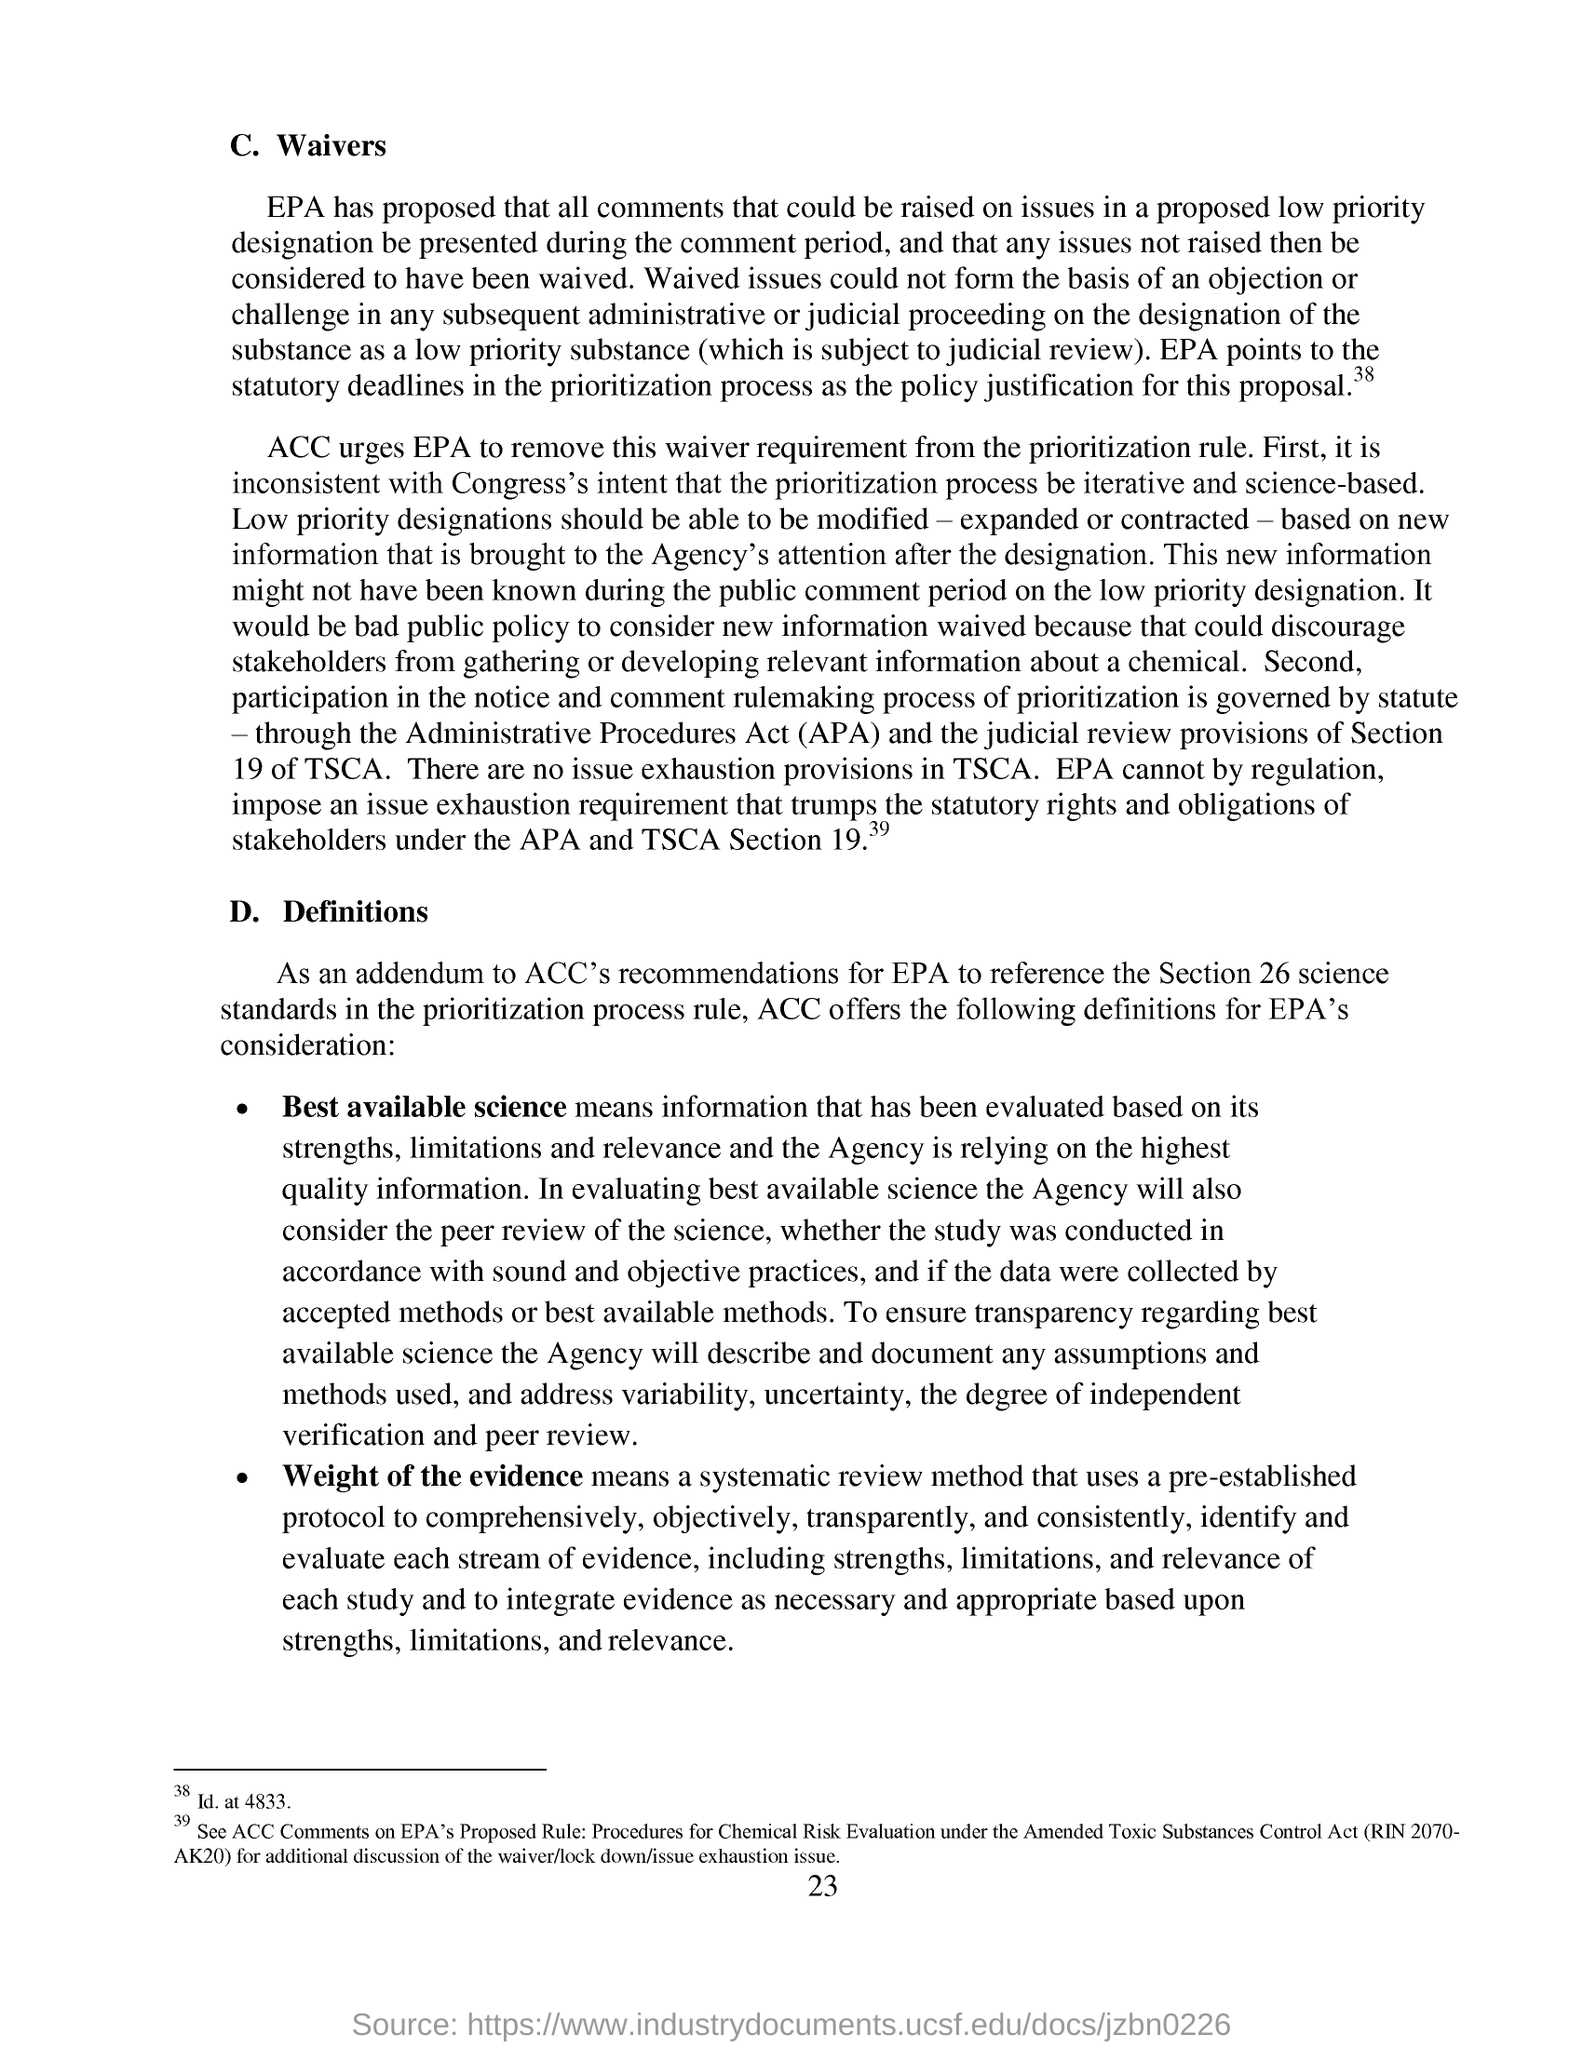Highlight a few significant elements in this photo. The suggestion is to remove the waiver requirement from the prioritization rule, as requested by the organization. APA stands for the Administrative Procedures Act, which is a law that sets out the rules and procedures for making and enforcing administrative decisions in a government agency or public authority. It is important to be able to modify, expand, or contract low priority designations. 